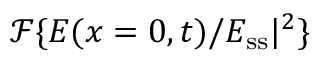<formula> <loc_0><loc_0><loc_500><loc_500>\mathcal { F } \{ E ( x = 0 , t ) / E _ { s s } | ^ { 2 } \}</formula> 